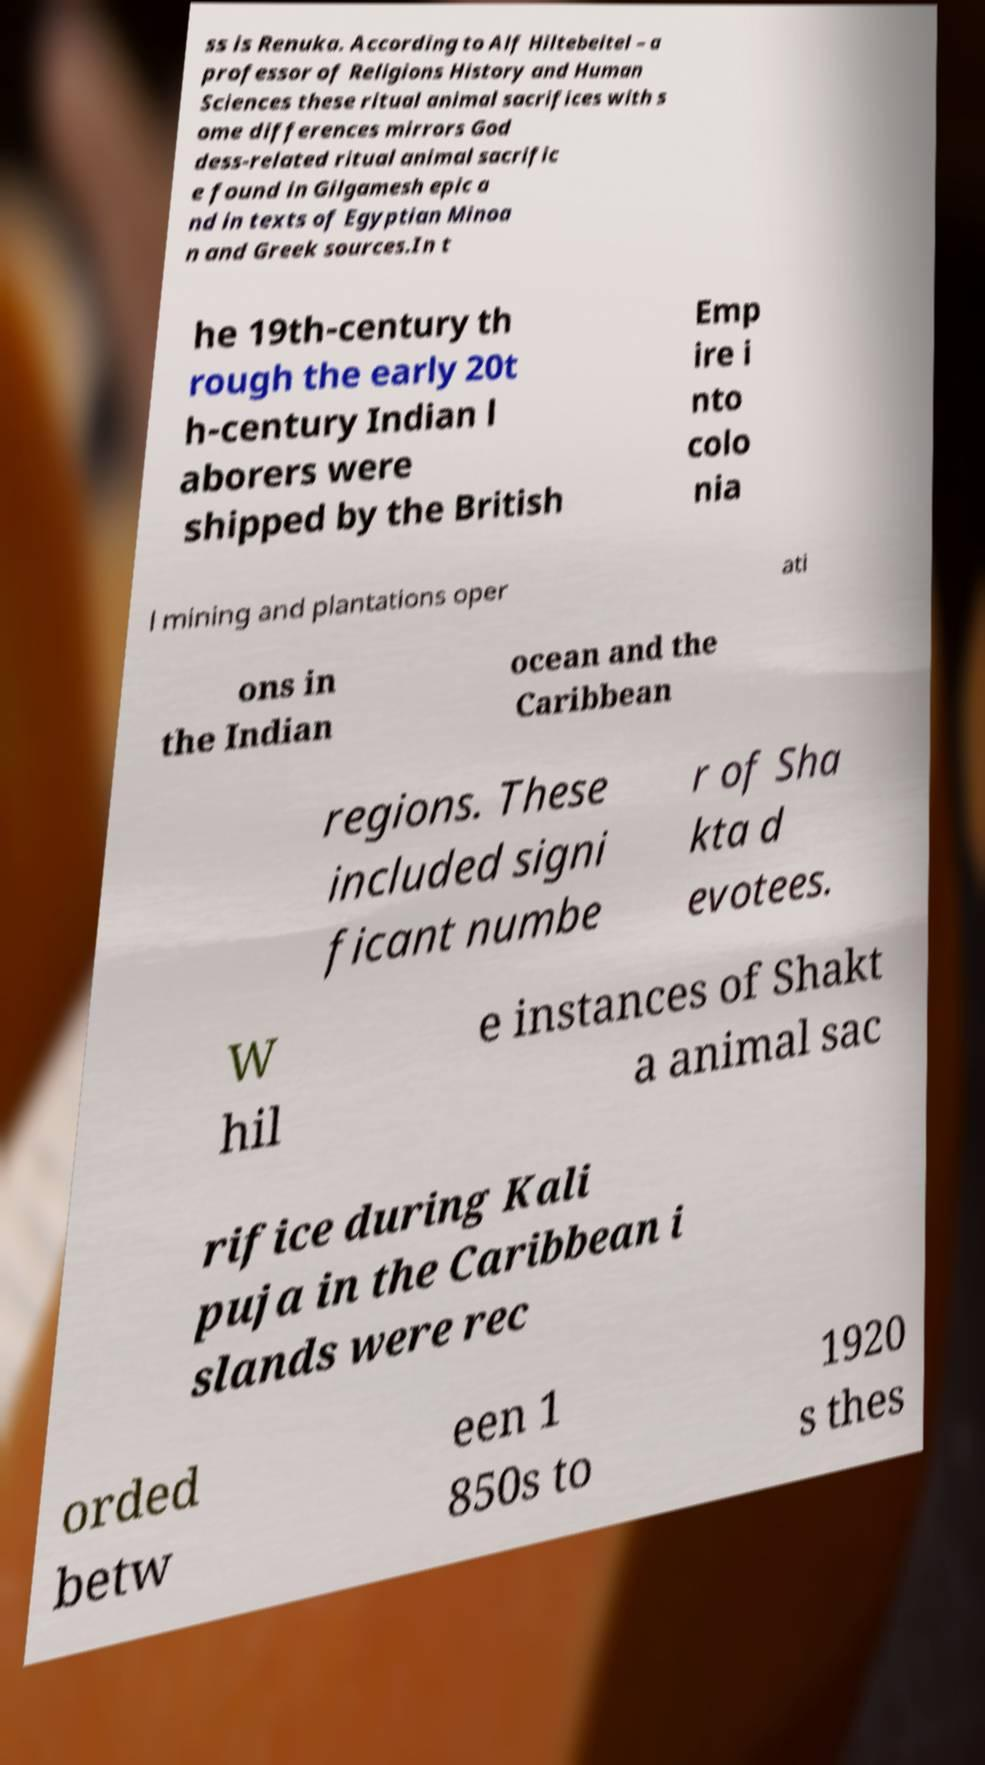Please identify and transcribe the text found in this image. ss is Renuka. According to Alf Hiltebeitel – a professor of Religions History and Human Sciences these ritual animal sacrifices with s ome differences mirrors God dess-related ritual animal sacrific e found in Gilgamesh epic a nd in texts of Egyptian Minoa n and Greek sources.In t he 19th-century th rough the early 20t h-century Indian l aborers were shipped by the British Emp ire i nto colo nia l mining and plantations oper ati ons in the Indian ocean and the Caribbean regions. These included signi ficant numbe r of Sha kta d evotees. W hil e instances of Shakt a animal sac rifice during Kali puja in the Caribbean i slands were rec orded betw een 1 850s to 1920 s thes 